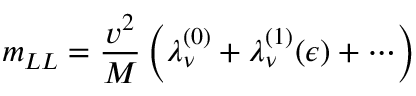<formula> <loc_0><loc_0><loc_500><loc_500>m _ { L L } = { \frac { v ^ { 2 } } { M } } \left ( \lambda _ { \nu } ^ { ( 0 ) } + \lambda _ { \nu } ^ { ( 1 ) } ( \epsilon ) + \cdots \right )</formula> 